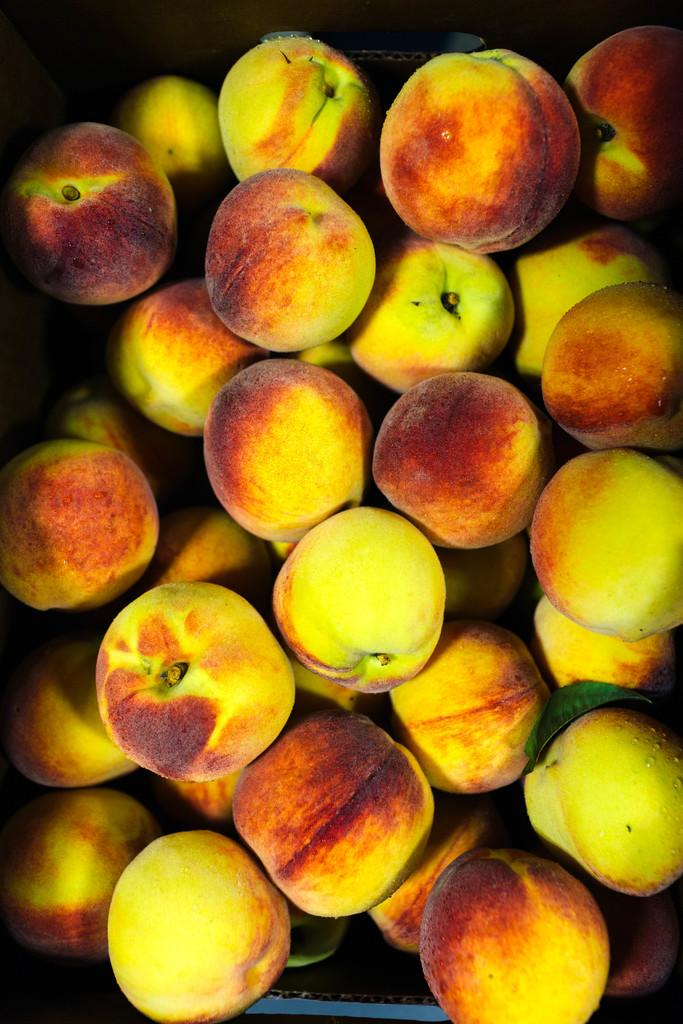What type of fruit is visible in the image? There is a bunch of apples in the image. Where are the apples located in the image? The apples are in a box. What type of expert advice can be seen in the image? There is no expert advice present in the image; it features a bunch of apples in a box. What type of berry is visible in the image? There is no berry present in the image; it features a bunch of apples. 